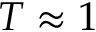<formula> <loc_0><loc_0><loc_500><loc_500>T \approx 1</formula> 